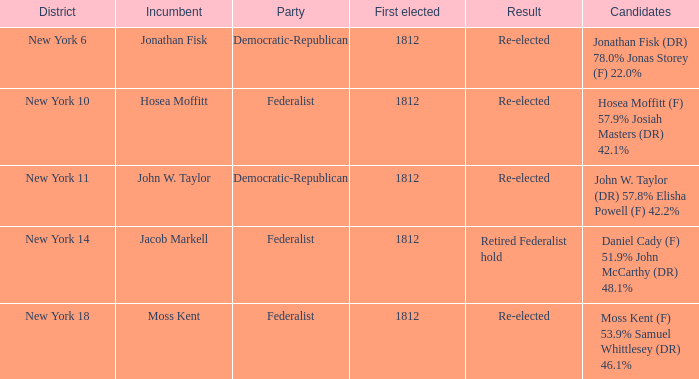Name the least first elected 1812.0. 